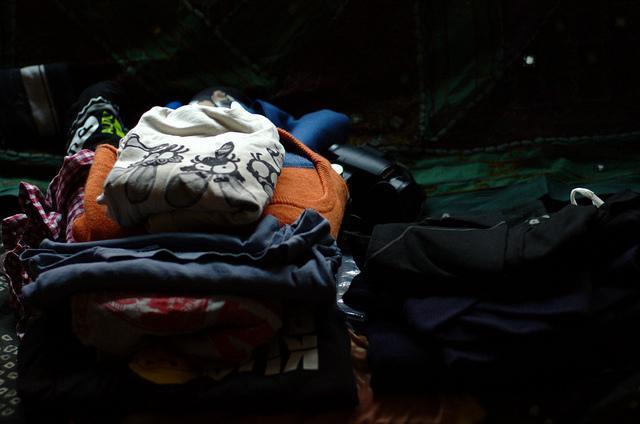How many handbags are in the picture?
Give a very brief answer. 2. 